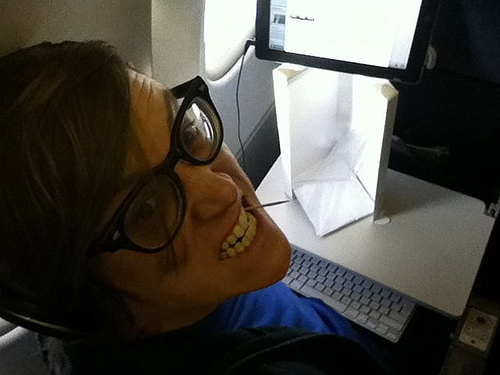Is the book to the right or to the left of him? The book is to the right of the guy. 